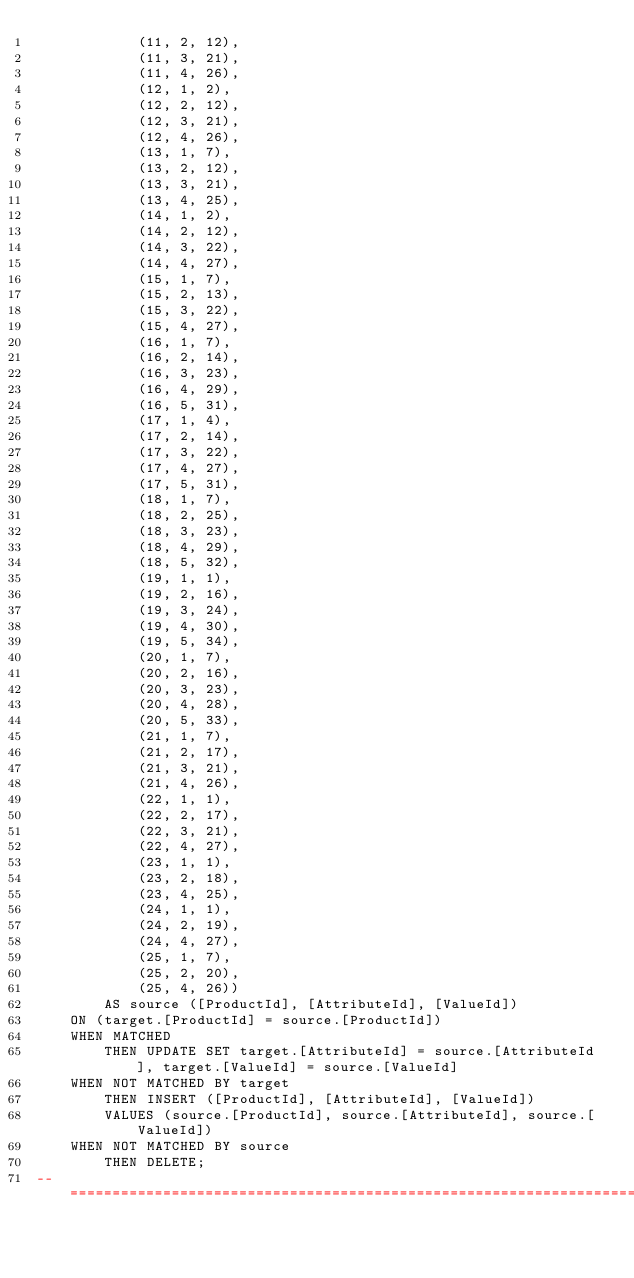<code> <loc_0><loc_0><loc_500><loc_500><_SQL_>            (11, 2, 12),
            (11, 3, 21),
            (11, 4, 26),
            (12, 1, 2),
            (12, 2, 12),
            (12, 3, 21),
            (12, 4, 26),
            (13, 1, 7),
            (13, 2, 12),
            (13, 3, 21),
            (13, 4, 25),
            (14, 1, 2),
            (14, 2, 12),
            (14, 3, 22),
            (14, 4, 27),
            (15, 1, 7),
            (15, 2, 13),
            (15, 3, 22),
            (15, 4, 27),
            (16, 1, 7),
            (16, 2, 14),
            (16, 3, 23),
            (16, 4, 29),
            (16, 5, 31),
            (17, 1, 4),
            (17, 2, 14),
            (17, 3, 22),
            (17, 4, 27),
            (17, 5, 31),
            (18, 1, 7),
            (18, 2, 25),
            (18, 3, 23),
            (18, 4, 29),
            (18, 5, 32),
            (19, 1, 1),
            (19, 2, 16),
            (19, 3, 24),
            (19, 4, 30),
            (19, 5, 34),
            (20, 1, 7),
            (20, 2, 16),
            (20, 3, 23),
            (20, 4, 28),
            (20, 5, 33),
            (21, 1, 7),
            (21, 2, 17),
            (21, 3, 21),
            (21, 4, 26),
            (22, 1, 1),
            (22, 2, 17),
            (22, 3, 21),
            (22, 4, 27),
            (23, 1, 1),
            (23, 2, 18),
            (23, 4, 25),
            (24, 1, 1),
            (24, 2, 19),
            (24, 4, 27),
            (25, 1, 7),
            (25, 2, 20),
            (25, 4, 26)) 
        AS source ([ProductId], [AttributeId], [ValueId])
    ON (target.[ProductId] = source.[ProductId])
    WHEN MATCHED
        THEN UPDATE SET target.[AttributeId] = source.[AttributeId], target.[ValueId] = source.[ValueId]
    WHEN NOT MATCHED BY target
        THEN INSERT ([ProductId], [AttributeId], [ValueId])
        VALUES (source.[ProductId], source.[AttributeId], source.[ValueId])
    WHEN NOT MATCHED BY source
        THEN DELETE;
--============================================================================</code> 